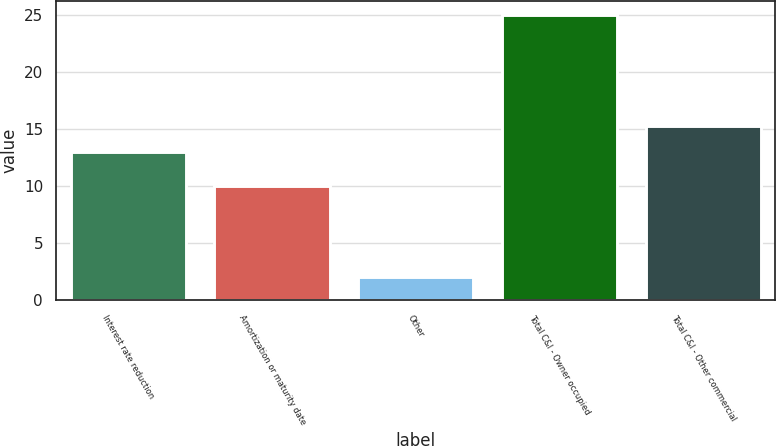Convert chart. <chart><loc_0><loc_0><loc_500><loc_500><bar_chart><fcel>Interest rate reduction<fcel>Amortization or maturity date<fcel>Other<fcel>Total C&I - Owner occupied<fcel>Total C&I - Other commercial<nl><fcel>13<fcel>10<fcel>2<fcel>25<fcel>15.3<nl></chart> 